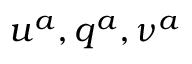Convert formula to latex. <formula><loc_0><loc_0><loc_500><loc_500>u ^ { a } , q ^ { a } , \nu ^ { a }</formula> 